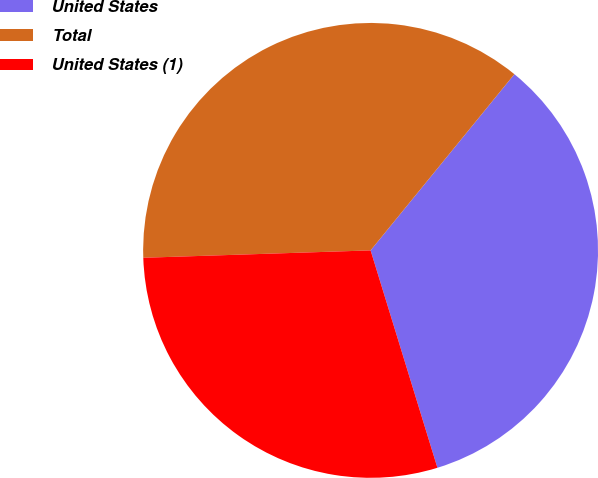Convert chart. <chart><loc_0><loc_0><loc_500><loc_500><pie_chart><fcel>United States<fcel>Total<fcel>United States (1)<nl><fcel>34.36%<fcel>36.41%<fcel>29.23%<nl></chart> 